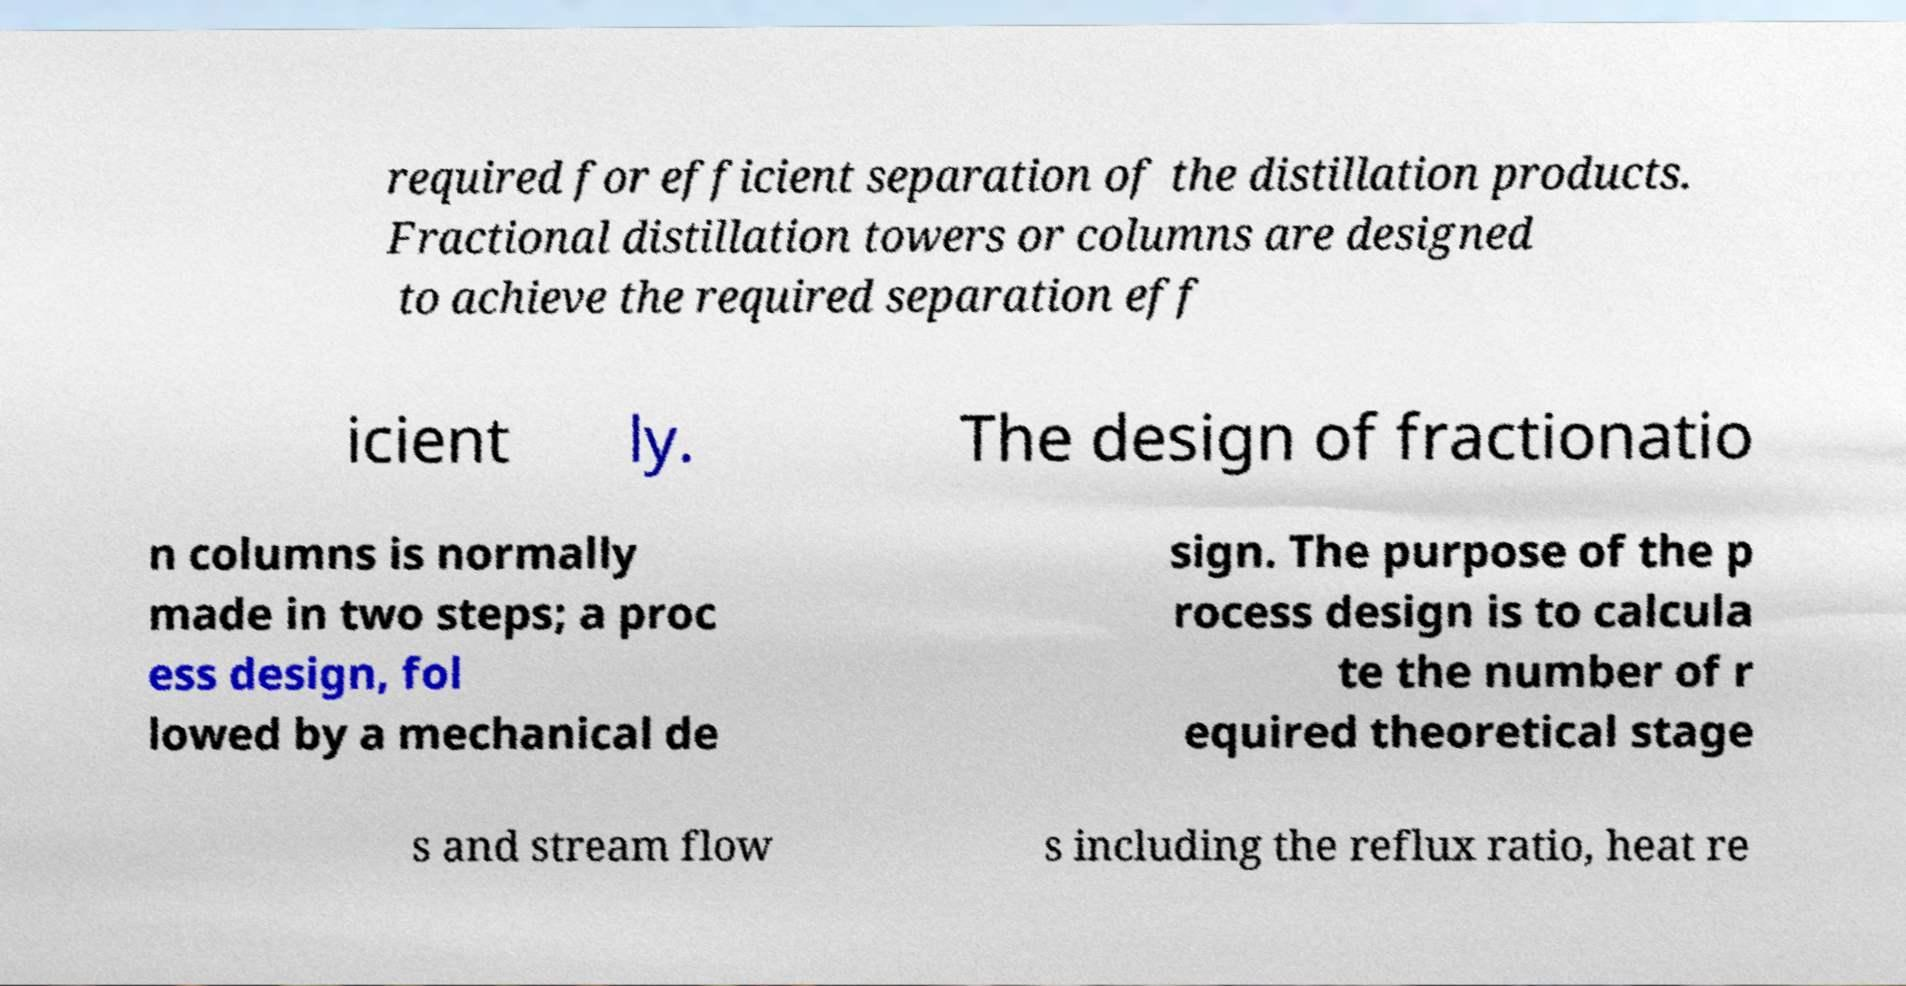Please identify and transcribe the text found in this image. required for efficient separation of the distillation products. Fractional distillation towers or columns are designed to achieve the required separation eff icient ly. The design of fractionatio n columns is normally made in two steps; a proc ess design, fol lowed by a mechanical de sign. The purpose of the p rocess design is to calcula te the number of r equired theoretical stage s and stream flow s including the reflux ratio, heat re 